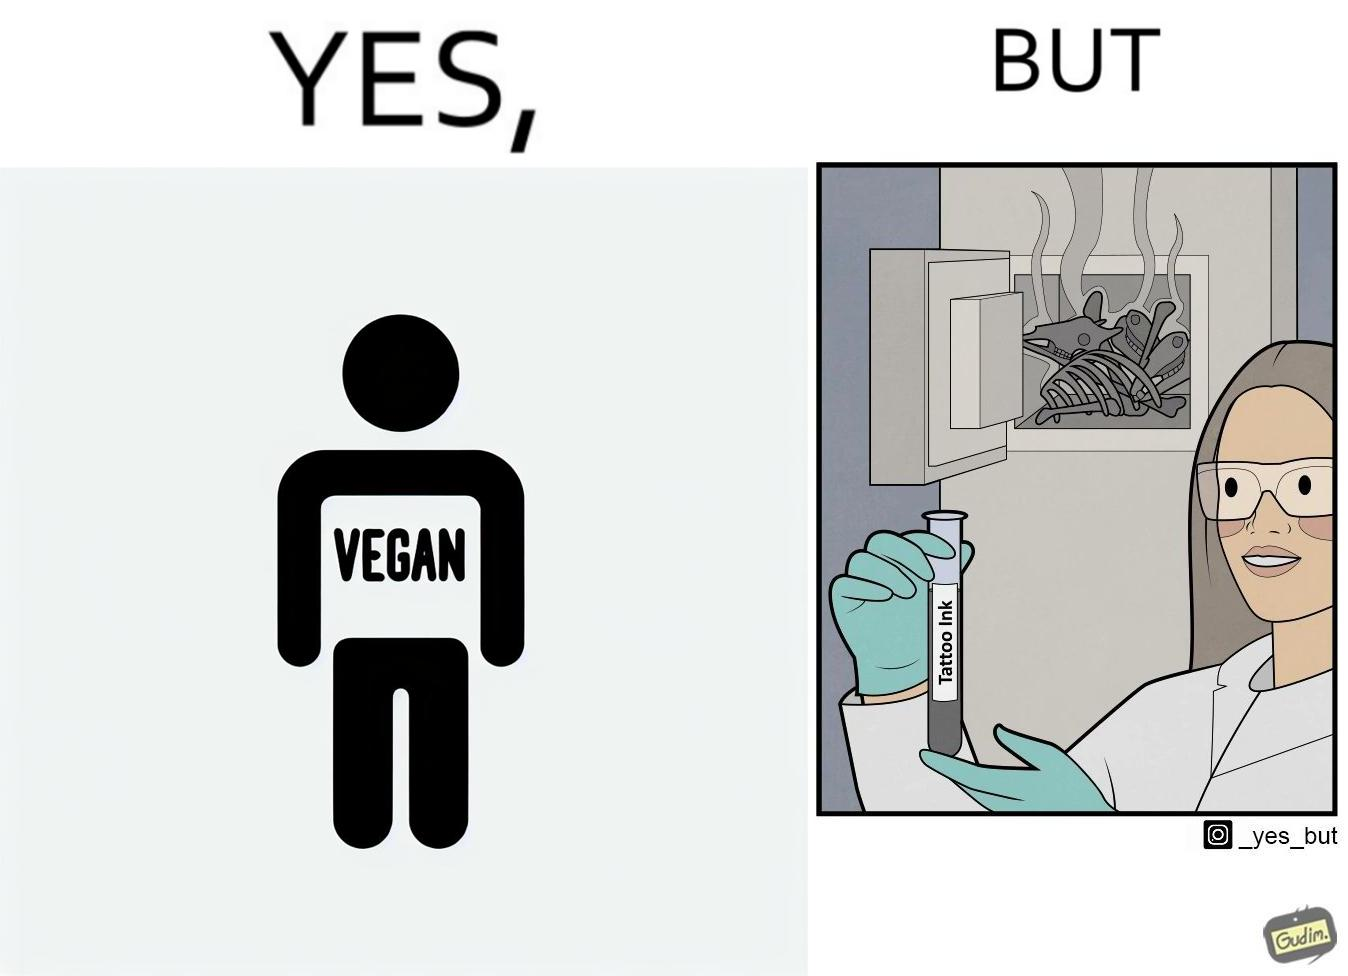Is this a satirical image? Yes, this image is satirical. 